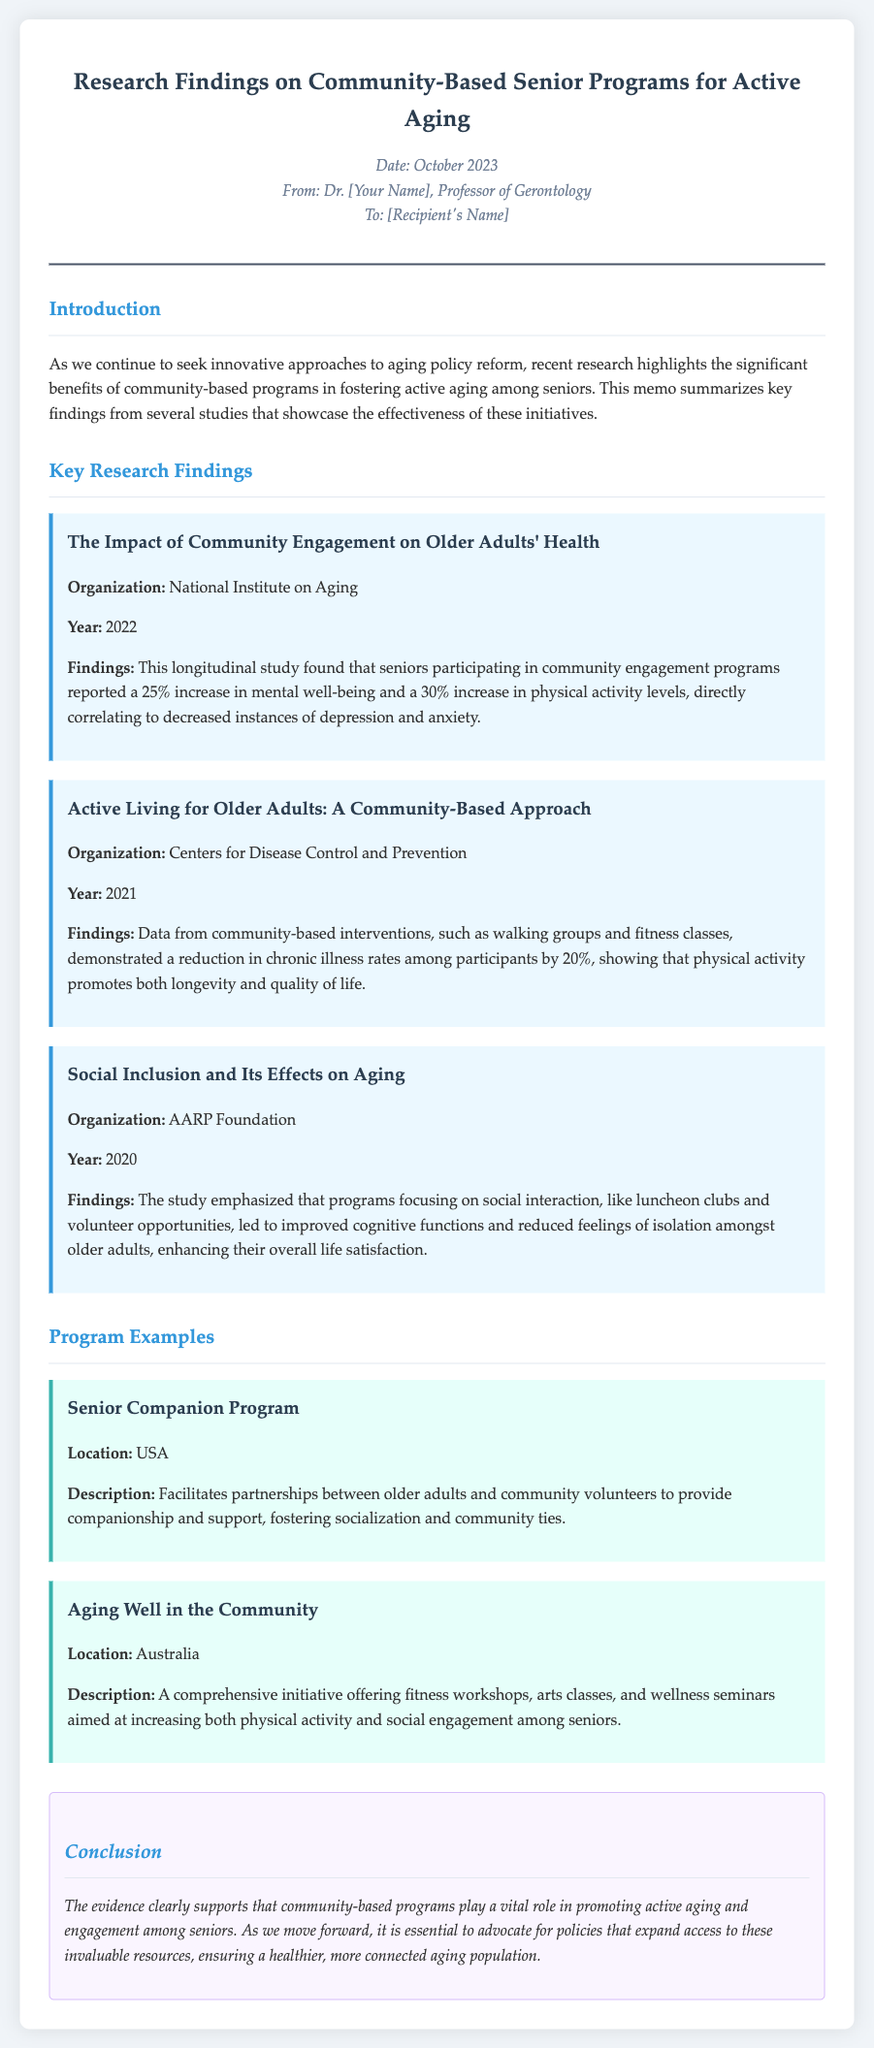what is the title of the memo? The title of the memo is summarized in the header of the document.
Answer: Research Findings on Community-Based Senior Programs for Active Aging what year was the study by the National Institute on Aging published? The year of the study can be found under the study details in the document.
Answer: 2022 what percentage increase in mental well-being was reported by seniors participating in community engagement programs? The percentage increase is mentioned in the findings of the National Institute on Aging study.
Answer: 25% which organization conducted the study on social inclusion and its effects on aging? The organization is listed with the study details in the research findings section.
Answer: AARP Foundation what types of activities are included in the "Aging Well in the Community" program? The activities can be inferred from the program description provided in the document.
Answer: fitness workshops, arts classes, and wellness seminars which program fosters companionship between older adults and community volunteers? The program name is specified in the program examples section.
Answer: Senior Companion Program how much did chronic illness rates reduce among participants according to the CDC study? The reduction value is stated in the findings of the Centers for Disease Control and Prevention study.
Answer: 20% what is the main conclusion drawn from the research findings? The conclusion is summarized at the end of the memo, emphasizing the importance of community-based programs.
Answer: community-based programs play a vital role in promoting active aging and engagement among seniors what location is mentioned for the "Aging Well in the Community" program? The location is indicated in the program examples for that specific program.
Answer: Australia how does the study from AARP Foundation impact feelings of isolation among older adults? The impact is summarized in the findings regarding social interaction programs.
Answer: reduced feelings of isolation 